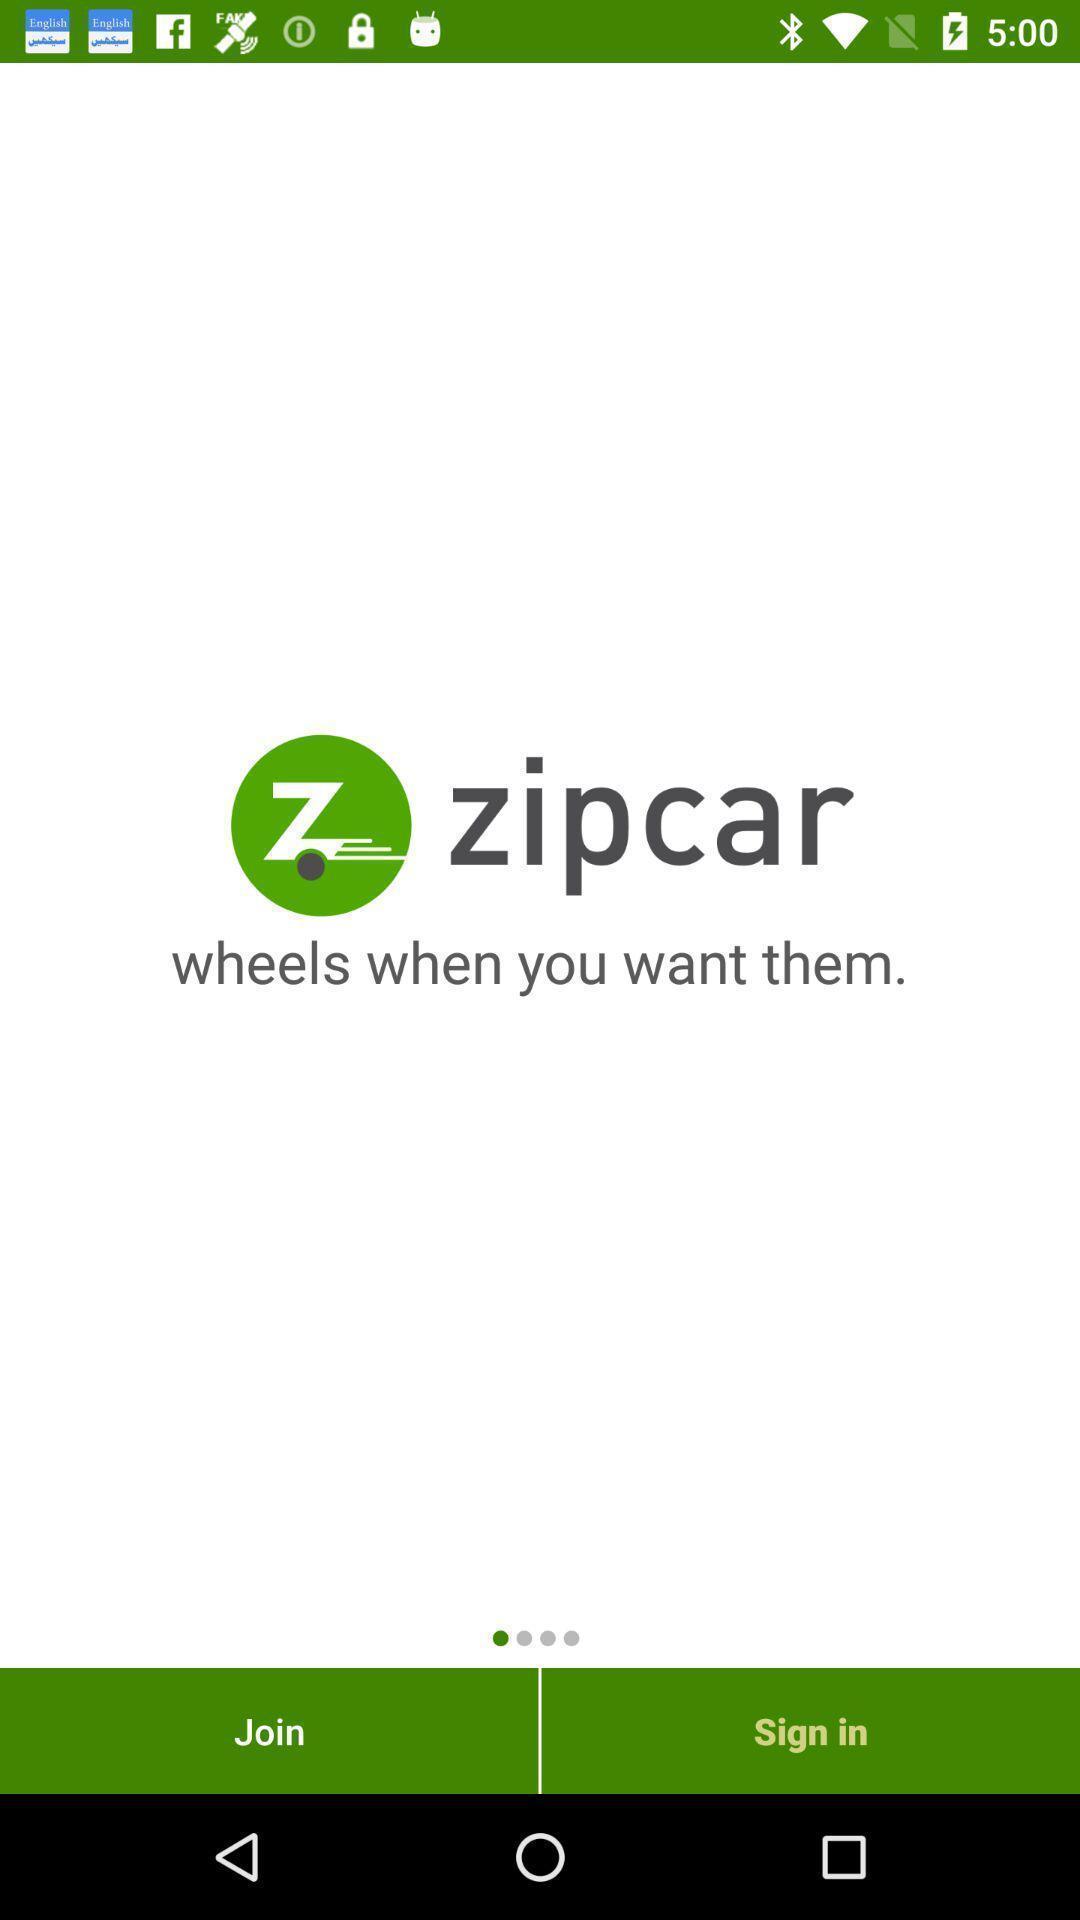Describe this image in words. Welcome page. 